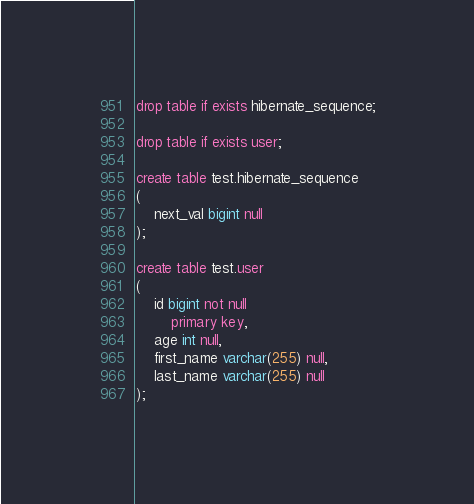Convert code to text. <code><loc_0><loc_0><loc_500><loc_500><_SQL_>drop table if exists hibernate_sequence;

drop table if exists user;

create table test.hibernate_sequence
(
    next_val bigint null
);

create table test.user
(
    id bigint not null
        primary key,
    age int null,
    first_name varchar(255) null,
    last_name varchar(255) null
);</code> 